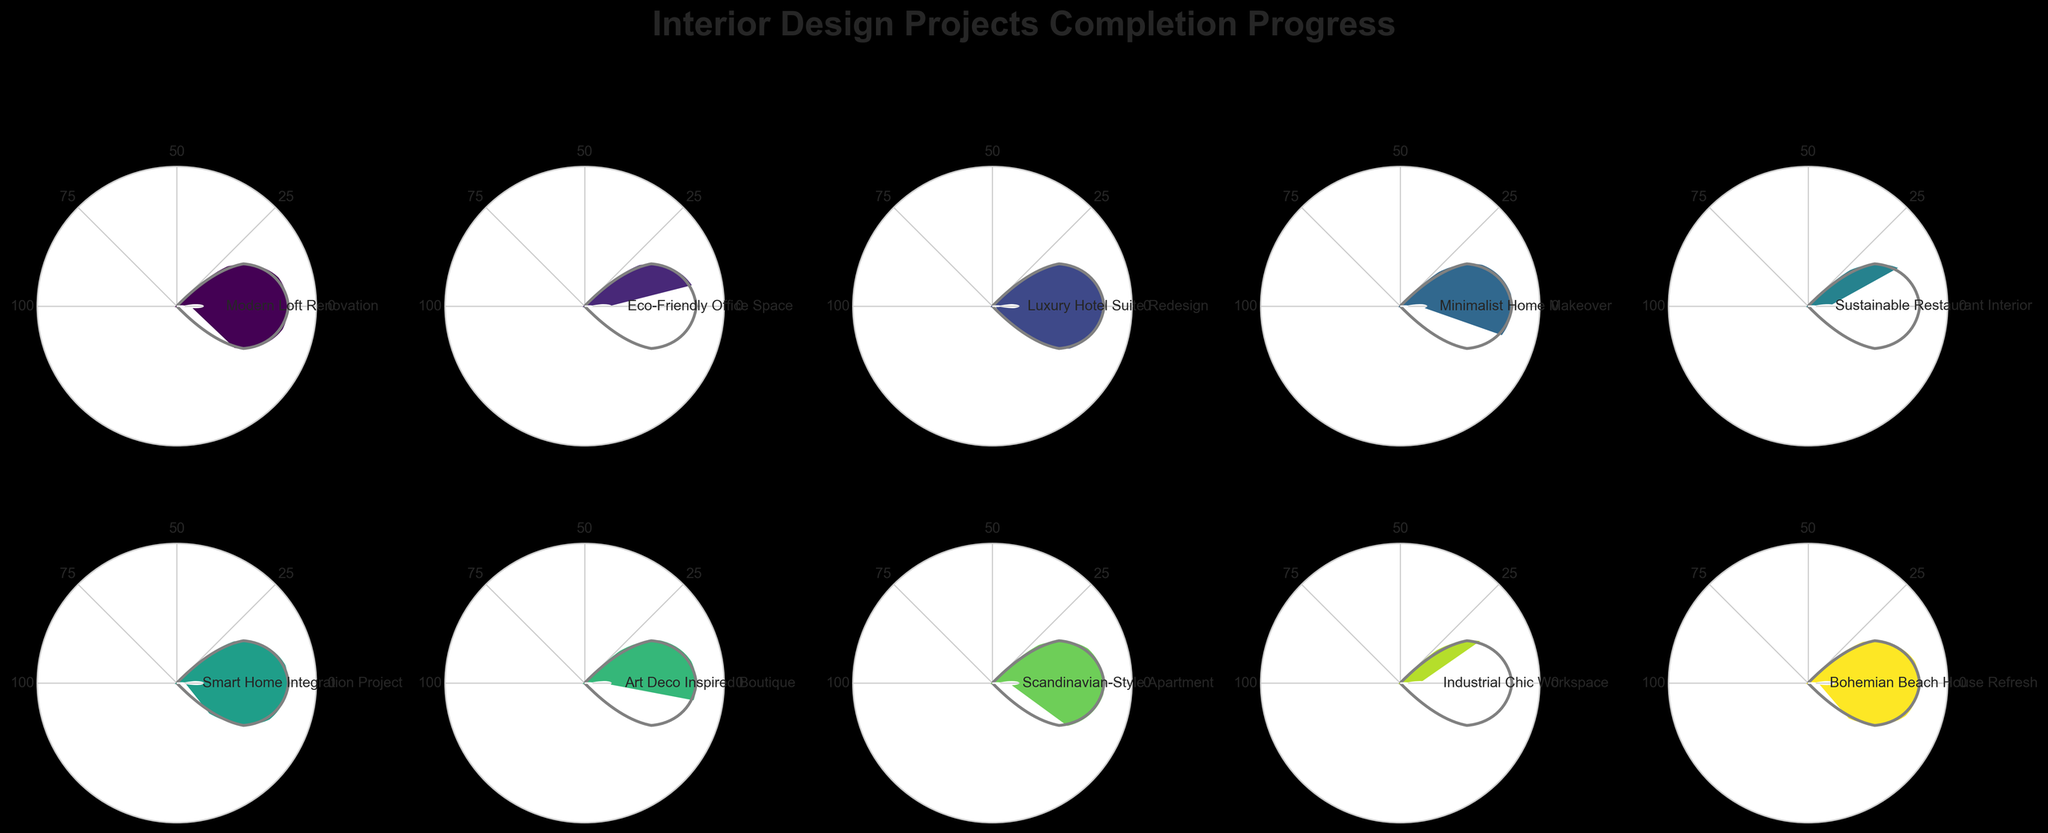What is the title of the figure? The title is usually displayed at the top of the figure. In this case, it is located above the gauge charts.
Answer: Interior Design Projects Completion Progress How many ongoing interior design projects are shown in the figure? The gauge charts each represent a separate interior design project. Counting the distinct charts, you can see there are a total of ten projects.
Answer: 10 Which project has the highest completion percentage? By observing each gauge chart and comparing their completion percentages, the project labeled "Luxury Hotel Suite Redesign" has the highest value at 95%.
Answer: Luxury Hotel Suite Redesign Which two projects have the lowest completion percentages? By looking at the gauge charts, the projects with the lowest percentages are "Industrial Chic Workspace" at 29% and "Sustainable Restaurant Interior" at 33%.
Answer: Industrial Chic Workspace and Sustainable Restaurant Interior What is the average completion percentage of all projects? To find the average, sum all the completion percentages and divide by the number of projects: (78 + 42 + 95 + 61 + 33 + 87 + 56 + 72 + 29 + 84) / 10 = 63.7%.
Answer: 63.7% Is the "Smart Home Integration Project" more complete than the "Bohemian Beach House Refresh"? By comparing the completion percentages shown in their respective gauge charts, "Smart Home Integration Project" is at 87%, while "Bohemian Beach House Refresh" is at 84%. Thus, it is slightly more complete.
Answer: Yes Which projects are more than 75% complete? Identifying the gauge charts with percentages above 75%: "Modern Loft Renovation" (78%), "Luxury Hotel Suite Redesign" (95%), "Smart Home Integration Project" (87%), and "Bohemian Beach House Refresh" (84%).
Answer: Modern Loft Renovation, Luxury Hotel Suite Redesign, Smart Home Integration Project, and Bohemian Beach House Refresh How many projects have a completion percentage below 50%? By looking at their completion percentages, the projects "Eco-Friendly Office Space" (42%), "Sustainable Restaurant Interior" (33%), and "Industrial Chic Workspace" (29%) are below 50%. There are three such projects.
Answer: 3 Which project is closest to being half complete? By observing the gauge charts, "Minimalist Home Makeover" has a completion percentage of 61%, which is closest to 50% among all the projects.
Answer: Minimalist Home Makeover What is the total combined completion percentage of the "Eco-Friendly Office Space" and "Scandinavian-Style Apartment" projects? Summing the percentages for these two projects: 42% (Eco-Friendly Office Space) + 72% (Scandinavian-Style Apartment) = 114%.
Answer: 114% 